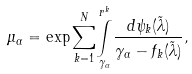Convert formula to latex. <formula><loc_0><loc_0><loc_500><loc_500>\mu _ { \alpha } = \exp \underset { k = 1 } { \overset { N } { \sum } } \underset { \gamma _ { \alpha } } { \overset { r ^ { k } } { \int } } \frac { d \psi _ { k } ( \tilde { \lambda } ) } { \gamma _ { \alpha } - f _ { k } ( \tilde { \lambda } ) } ,</formula> 